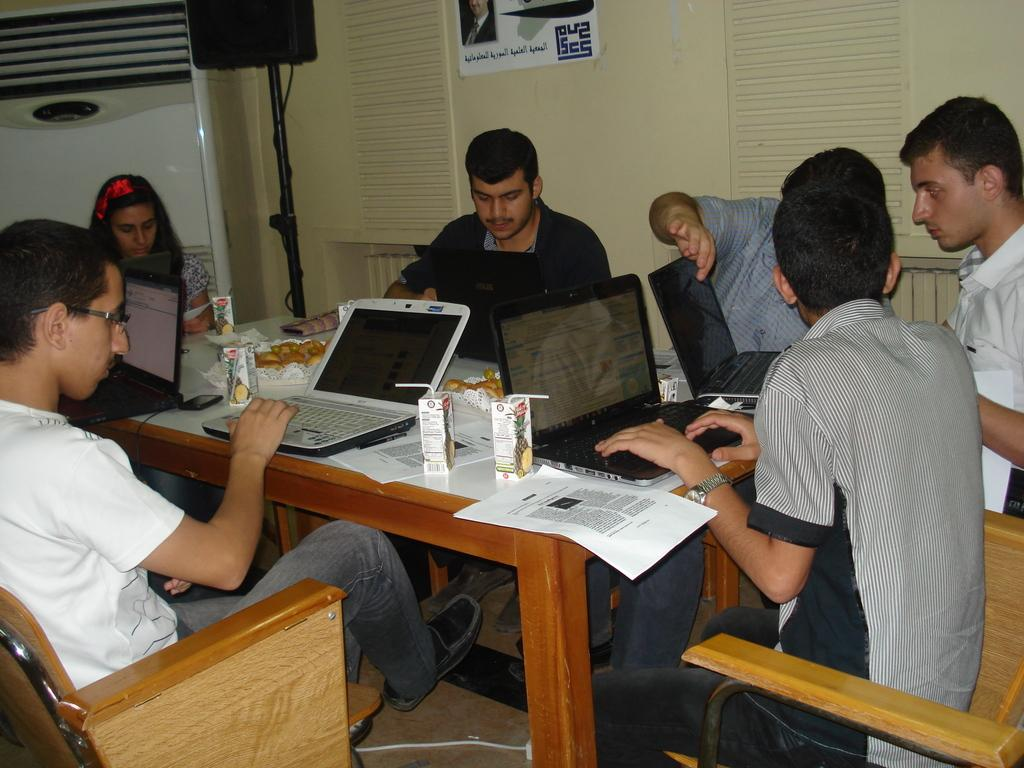How many people are in the image? There are people in the image. What are the people doing in the image? The people are working on a laptop. What type of table is in the image? There is a wooden table in the image. What is on the wooden table? A laptop, a food item, and papers are present on the table. How many boys are playing with the net in the image? There is no net or boys present in the image. What type of hot item is on the table in the image? There is no hot item present on the table in the image. 